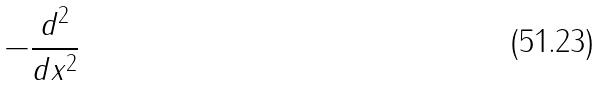<formula> <loc_0><loc_0><loc_500><loc_500>- \frac { d ^ { 2 } } { d x ^ { 2 } }</formula> 